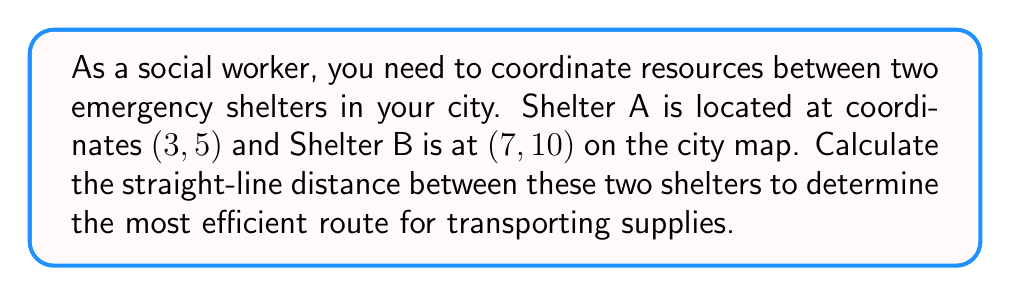Provide a solution to this math problem. To find the distance between two points on a coordinate plane, we can use the distance formula, which is derived from the Pythagorean theorem:

$$d = \sqrt{(x_2 - x_1)^2 + (y_2 - y_1)^2}$$

Where $(x_1, y_1)$ are the coordinates of the first point and $(x_2, y_2)$ are the coordinates of the second point.

Given:
- Shelter A: $(x_1, y_1) = (3, 5)$
- Shelter B: $(x_2, y_2) = (7, 10)$

Step 1: Substitute the values into the distance formula.
$$d = \sqrt{(7 - 3)^2 + (10 - 5)^2}$$

Step 2: Simplify the expressions inside the parentheses.
$$d = \sqrt{4^2 + 5^2}$$

Step 3: Calculate the squares.
$$d = \sqrt{16 + 25}$$

Step 4: Add the values under the square root.
$$d = \sqrt{41}$$

Step 5: Simplify the square root (if possible). In this case, $\sqrt{41}$ cannot be simplified further.

Therefore, the distance between Shelter A and Shelter B is $\sqrt{41}$ units on the city map.
Answer: $\sqrt{41}$ units 